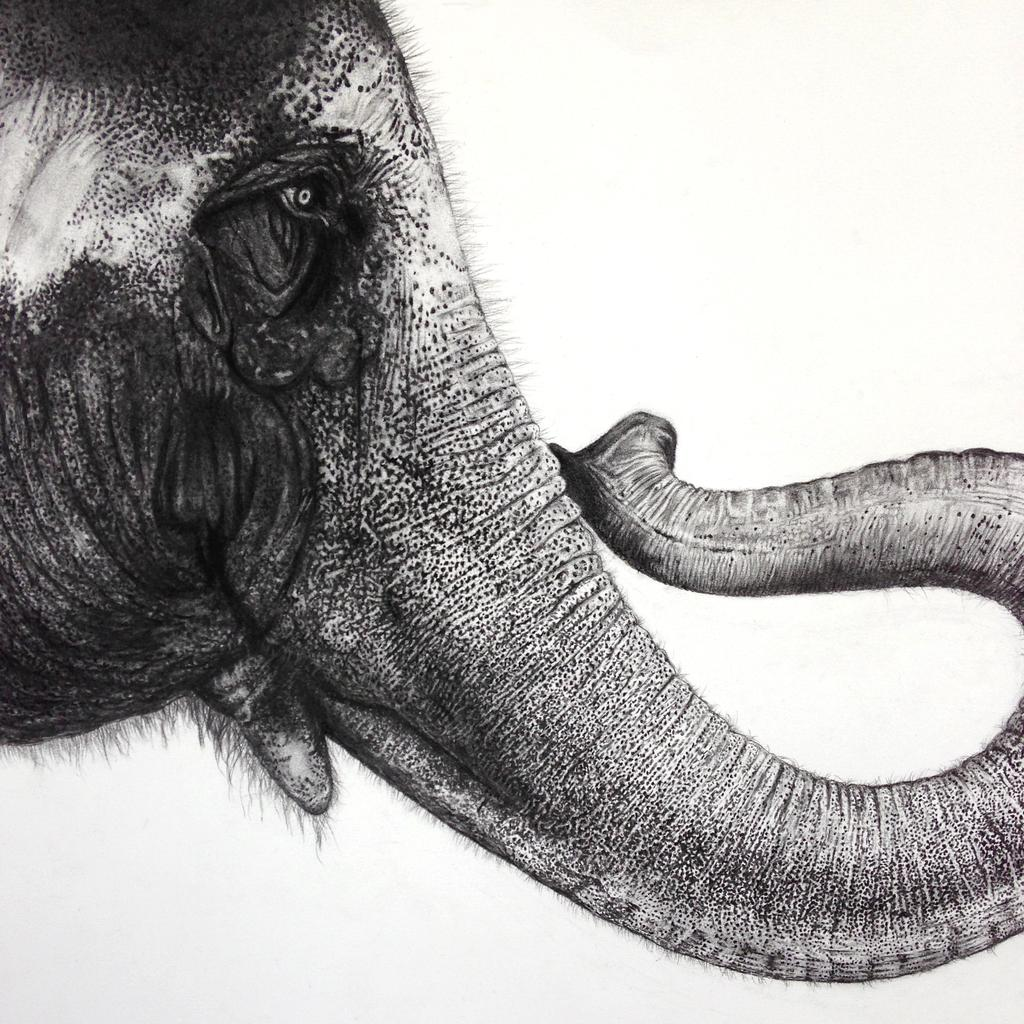What is the color scheme of the image? The image is black and white. What subject is depicted in the image? There is a picture of an elephant in the image. Can you tell me how many buttons are on the elephant's back in the image? There are no buttons present on the elephant in the image, as it is a black and white picture of an elephant. What is the temperature of the river in the image? There is no river present in the image; it only features a picture of an elephant. 